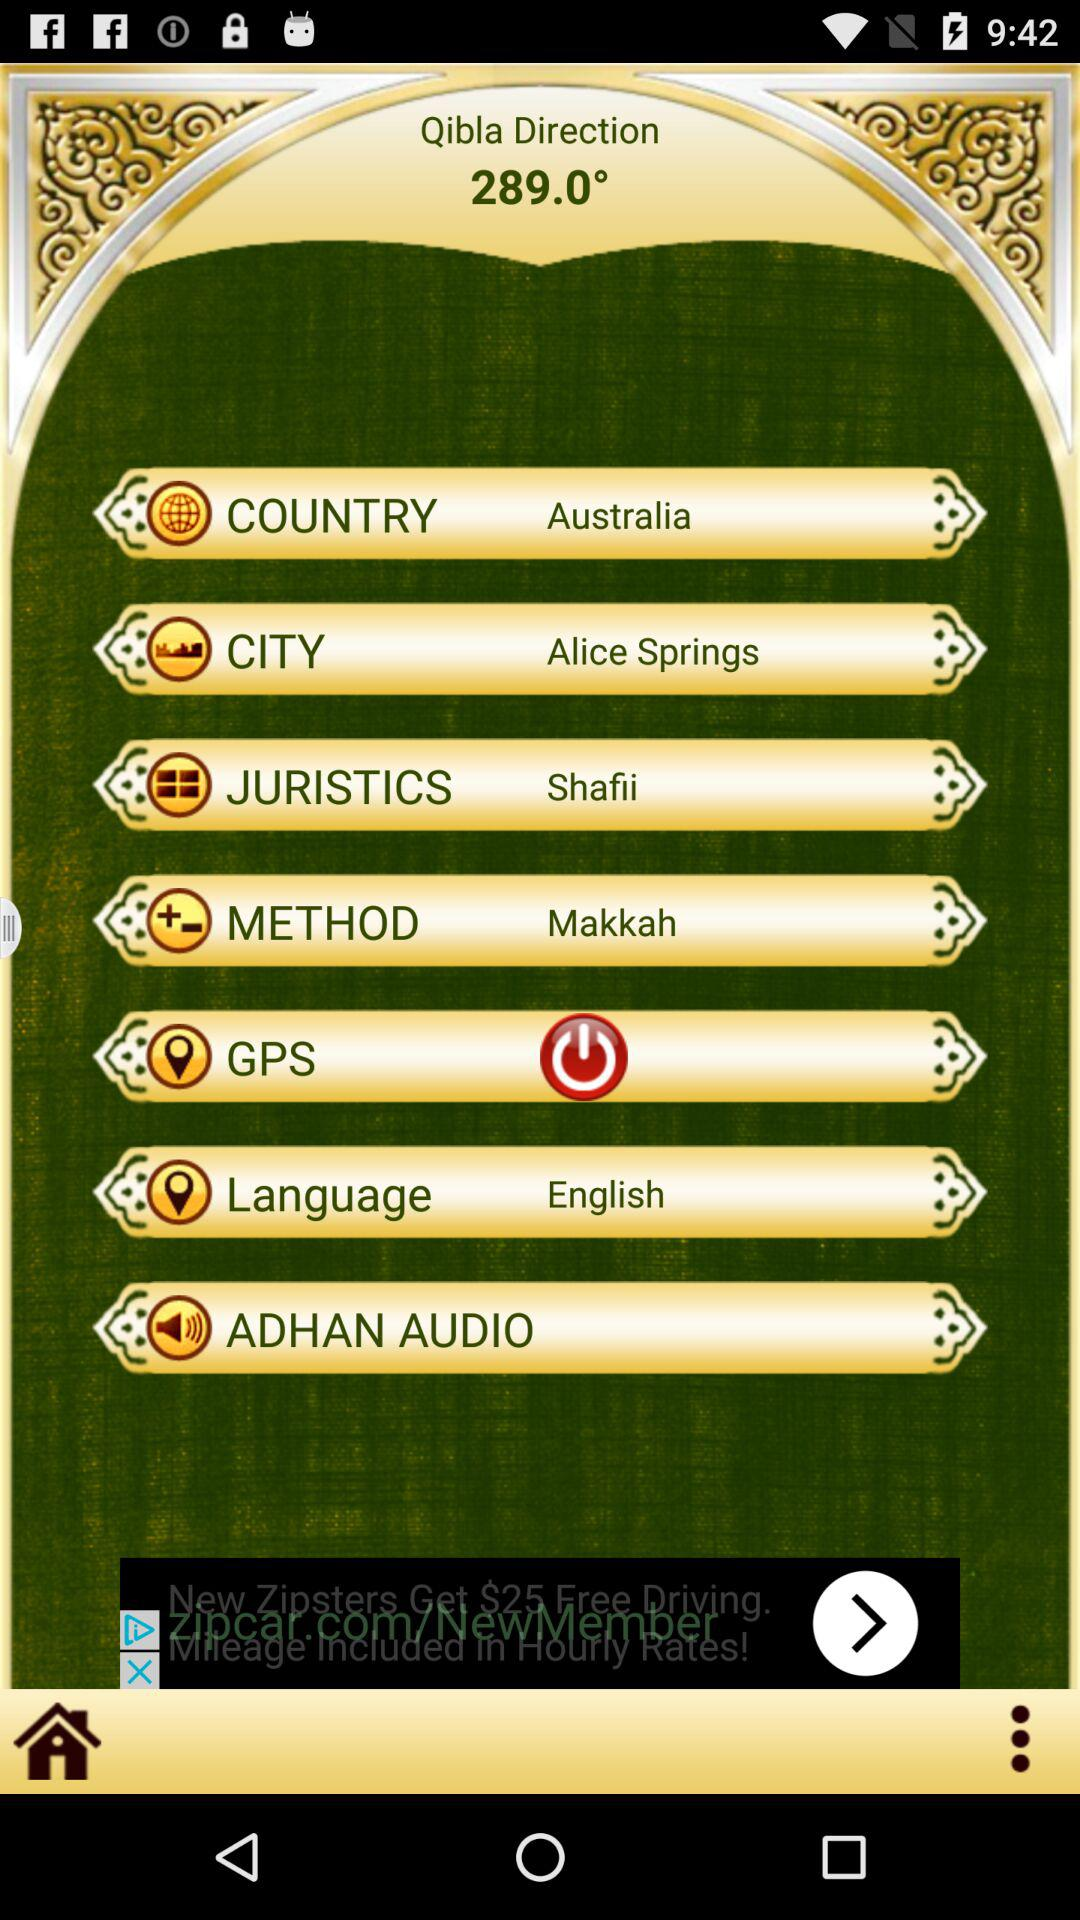Which is the selected language? The selected language is English. 